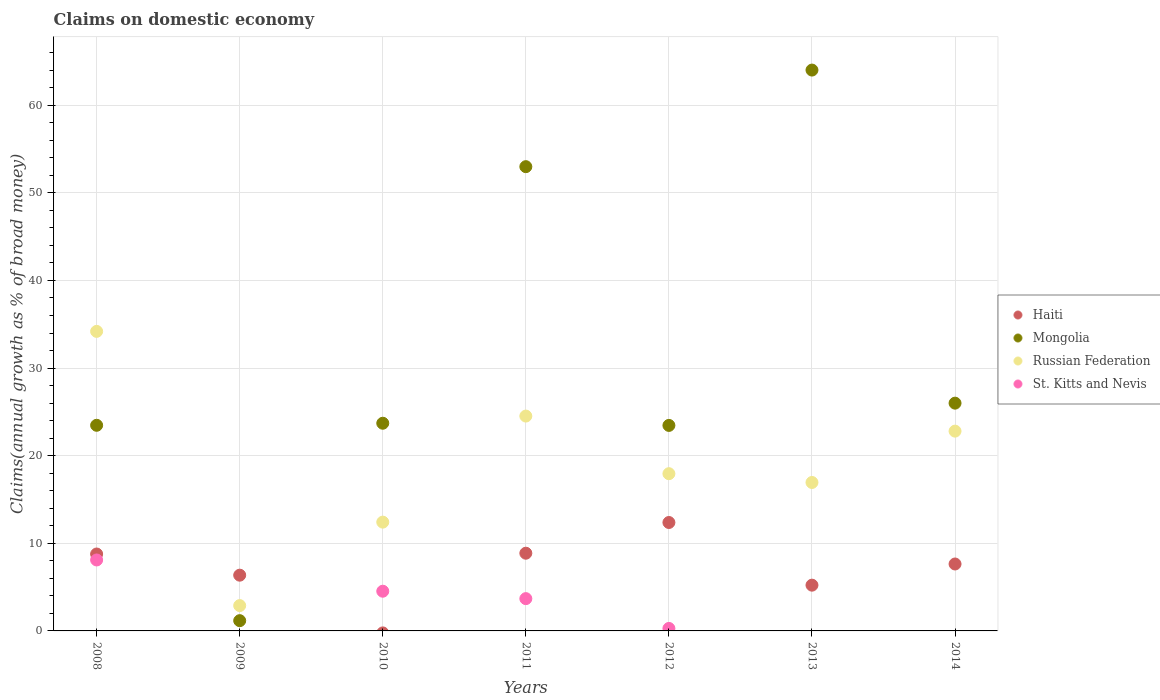Is the number of dotlines equal to the number of legend labels?
Keep it short and to the point. No. What is the percentage of broad money claimed on domestic economy in Russian Federation in 2010?
Offer a terse response. 12.42. Across all years, what is the maximum percentage of broad money claimed on domestic economy in Russian Federation?
Provide a succinct answer. 34.19. Across all years, what is the minimum percentage of broad money claimed on domestic economy in Mongolia?
Your response must be concise. 1.17. In which year was the percentage of broad money claimed on domestic economy in Mongolia maximum?
Your answer should be very brief. 2013. What is the total percentage of broad money claimed on domestic economy in St. Kitts and Nevis in the graph?
Your answer should be compact. 16.6. What is the difference between the percentage of broad money claimed on domestic economy in Mongolia in 2011 and that in 2014?
Your answer should be very brief. 26.99. What is the difference between the percentage of broad money claimed on domestic economy in St. Kitts and Nevis in 2014 and the percentage of broad money claimed on domestic economy in Mongolia in 2009?
Keep it short and to the point. -1.17. What is the average percentage of broad money claimed on domestic economy in Haiti per year?
Offer a terse response. 7.03. In the year 2009, what is the difference between the percentage of broad money claimed on domestic economy in Mongolia and percentage of broad money claimed on domestic economy in Russian Federation?
Your answer should be very brief. -1.72. What is the ratio of the percentage of broad money claimed on domestic economy in Haiti in 2008 to that in 2012?
Give a very brief answer. 0.71. Is the difference between the percentage of broad money claimed on domestic economy in Mongolia in 2009 and 2012 greater than the difference between the percentage of broad money claimed on domestic economy in Russian Federation in 2009 and 2012?
Ensure brevity in your answer.  No. What is the difference between the highest and the second highest percentage of broad money claimed on domestic economy in Mongolia?
Provide a short and direct response. 11.02. What is the difference between the highest and the lowest percentage of broad money claimed on domestic economy in Russian Federation?
Provide a short and direct response. 31.3. In how many years, is the percentage of broad money claimed on domestic economy in Mongolia greater than the average percentage of broad money claimed on domestic economy in Mongolia taken over all years?
Provide a succinct answer. 2. Is the sum of the percentage of broad money claimed on domestic economy in Haiti in 2008 and 2012 greater than the maximum percentage of broad money claimed on domestic economy in Mongolia across all years?
Offer a terse response. No. Is the percentage of broad money claimed on domestic economy in St. Kitts and Nevis strictly greater than the percentage of broad money claimed on domestic economy in Mongolia over the years?
Offer a very short reply. No. Does the graph contain any zero values?
Your answer should be very brief. Yes. How many legend labels are there?
Keep it short and to the point. 4. What is the title of the graph?
Provide a short and direct response. Claims on domestic economy. Does "Canada" appear as one of the legend labels in the graph?
Provide a succinct answer. No. What is the label or title of the X-axis?
Provide a short and direct response. Years. What is the label or title of the Y-axis?
Offer a terse response. Claims(annual growth as % of broad money). What is the Claims(annual growth as % of broad money) in Haiti in 2008?
Provide a short and direct response. 8.78. What is the Claims(annual growth as % of broad money) in Mongolia in 2008?
Provide a short and direct response. 23.47. What is the Claims(annual growth as % of broad money) of Russian Federation in 2008?
Provide a succinct answer. 34.19. What is the Claims(annual growth as % of broad money) of St. Kitts and Nevis in 2008?
Your response must be concise. 8.1. What is the Claims(annual growth as % of broad money) in Haiti in 2009?
Your answer should be compact. 6.36. What is the Claims(annual growth as % of broad money) of Mongolia in 2009?
Your answer should be compact. 1.17. What is the Claims(annual growth as % of broad money) in Russian Federation in 2009?
Ensure brevity in your answer.  2.89. What is the Claims(annual growth as % of broad money) of St. Kitts and Nevis in 2009?
Ensure brevity in your answer.  0. What is the Claims(annual growth as % of broad money) in Mongolia in 2010?
Keep it short and to the point. 23.7. What is the Claims(annual growth as % of broad money) of Russian Federation in 2010?
Make the answer very short. 12.42. What is the Claims(annual growth as % of broad money) of St. Kitts and Nevis in 2010?
Make the answer very short. 4.53. What is the Claims(annual growth as % of broad money) of Haiti in 2011?
Give a very brief answer. 8.87. What is the Claims(annual growth as % of broad money) of Mongolia in 2011?
Offer a very short reply. 52.99. What is the Claims(annual growth as % of broad money) in Russian Federation in 2011?
Give a very brief answer. 24.52. What is the Claims(annual growth as % of broad money) of St. Kitts and Nevis in 2011?
Your answer should be very brief. 3.68. What is the Claims(annual growth as % of broad money) of Haiti in 2012?
Offer a terse response. 12.37. What is the Claims(annual growth as % of broad money) in Mongolia in 2012?
Your answer should be very brief. 23.46. What is the Claims(annual growth as % of broad money) of Russian Federation in 2012?
Provide a succinct answer. 17.95. What is the Claims(annual growth as % of broad money) in St. Kitts and Nevis in 2012?
Provide a short and direct response. 0.28. What is the Claims(annual growth as % of broad money) in Haiti in 2013?
Offer a very short reply. 5.22. What is the Claims(annual growth as % of broad money) in Mongolia in 2013?
Offer a very short reply. 64.01. What is the Claims(annual growth as % of broad money) in Russian Federation in 2013?
Provide a succinct answer. 16.94. What is the Claims(annual growth as % of broad money) of St. Kitts and Nevis in 2013?
Your response must be concise. 0. What is the Claims(annual growth as % of broad money) of Haiti in 2014?
Provide a succinct answer. 7.64. What is the Claims(annual growth as % of broad money) of Mongolia in 2014?
Ensure brevity in your answer.  26. What is the Claims(annual growth as % of broad money) in Russian Federation in 2014?
Give a very brief answer. 22.8. Across all years, what is the maximum Claims(annual growth as % of broad money) in Haiti?
Provide a short and direct response. 12.37. Across all years, what is the maximum Claims(annual growth as % of broad money) in Mongolia?
Offer a very short reply. 64.01. Across all years, what is the maximum Claims(annual growth as % of broad money) of Russian Federation?
Offer a very short reply. 34.19. Across all years, what is the maximum Claims(annual growth as % of broad money) of St. Kitts and Nevis?
Your answer should be compact. 8.1. Across all years, what is the minimum Claims(annual growth as % of broad money) of Haiti?
Provide a succinct answer. 0. Across all years, what is the minimum Claims(annual growth as % of broad money) in Mongolia?
Your response must be concise. 1.17. Across all years, what is the minimum Claims(annual growth as % of broad money) of Russian Federation?
Offer a terse response. 2.89. What is the total Claims(annual growth as % of broad money) in Haiti in the graph?
Provide a succinct answer. 49.24. What is the total Claims(annual growth as % of broad money) of Mongolia in the graph?
Ensure brevity in your answer.  214.79. What is the total Claims(annual growth as % of broad money) of Russian Federation in the graph?
Keep it short and to the point. 131.71. What is the total Claims(annual growth as % of broad money) in St. Kitts and Nevis in the graph?
Make the answer very short. 16.6. What is the difference between the Claims(annual growth as % of broad money) of Haiti in 2008 and that in 2009?
Provide a succinct answer. 2.42. What is the difference between the Claims(annual growth as % of broad money) of Mongolia in 2008 and that in 2009?
Ensure brevity in your answer.  22.3. What is the difference between the Claims(annual growth as % of broad money) in Russian Federation in 2008 and that in 2009?
Give a very brief answer. 31.3. What is the difference between the Claims(annual growth as % of broad money) of Mongolia in 2008 and that in 2010?
Offer a terse response. -0.23. What is the difference between the Claims(annual growth as % of broad money) of Russian Federation in 2008 and that in 2010?
Offer a terse response. 21.77. What is the difference between the Claims(annual growth as % of broad money) of St. Kitts and Nevis in 2008 and that in 2010?
Your response must be concise. 3.57. What is the difference between the Claims(annual growth as % of broad money) in Haiti in 2008 and that in 2011?
Ensure brevity in your answer.  -0.09. What is the difference between the Claims(annual growth as % of broad money) of Mongolia in 2008 and that in 2011?
Provide a succinct answer. -29.52. What is the difference between the Claims(annual growth as % of broad money) in Russian Federation in 2008 and that in 2011?
Provide a succinct answer. 9.67. What is the difference between the Claims(annual growth as % of broad money) in St. Kitts and Nevis in 2008 and that in 2011?
Keep it short and to the point. 4.41. What is the difference between the Claims(annual growth as % of broad money) in Haiti in 2008 and that in 2012?
Offer a terse response. -3.6. What is the difference between the Claims(annual growth as % of broad money) in Mongolia in 2008 and that in 2012?
Your answer should be compact. 0.01. What is the difference between the Claims(annual growth as % of broad money) of Russian Federation in 2008 and that in 2012?
Offer a terse response. 16.24. What is the difference between the Claims(annual growth as % of broad money) in St. Kitts and Nevis in 2008 and that in 2012?
Ensure brevity in your answer.  7.82. What is the difference between the Claims(annual growth as % of broad money) of Haiti in 2008 and that in 2013?
Provide a succinct answer. 3.56. What is the difference between the Claims(annual growth as % of broad money) of Mongolia in 2008 and that in 2013?
Give a very brief answer. -40.54. What is the difference between the Claims(annual growth as % of broad money) of Russian Federation in 2008 and that in 2013?
Offer a terse response. 17.25. What is the difference between the Claims(annual growth as % of broad money) of Haiti in 2008 and that in 2014?
Give a very brief answer. 1.14. What is the difference between the Claims(annual growth as % of broad money) of Mongolia in 2008 and that in 2014?
Provide a succinct answer. -2.53. What is the difference between the Claims(annual growth as % of broad money) of Russian Federation in 2008 and that in 2014?
Provide a succinct answer. 11.39. What is the difference between the Claims(annual growth as % of broad money) in Mongolia in 2009 and that in 2010?
Provide a short and direct response. -22.53. What is the difference between the Claims(annual growth as % of broad money) in Russian Federation in 2009 and that in 2010?
Provide a short and direct response. -9.53. What is the difference between the Claims(annual growth as % of broad money) of Haiti in 2009 and that in 2011?
Offer a terse response. -2.51. What is the difference between the Claims(annual growth as % of broad money) of Mongolia in 2009 and that in 2011?
Offer a terse response. -51.82. What is the difference between the Claims(annual growth as % of broad money) of Russian Federation in 2009 and that in 2011?
Provide a short and direct response. -21.63. What is the difference between the Claims(annual growth as % of broad money) of Haiti in 2009 and that in 2012?
Make the answer very short. -6.01. What is the difference between the Claims(annual growth as % of broad money) in Mongolia in 2009 and that in 2012?
Offer a very short reply. -22.28. What is the difference between the Claims(annual growth as % of broad money) in Russian Federation in 2009 and that in 2012?
Ensure brevity in your answer.  -15.05. What is the difference between the Claims(annual growth as % of broad money) in Haiti in 2009 and that in 2013?
Offer a terse response. 1.14. What is the difference between the Claims(annual growth as % of broad money) of Mongolia in 2009 and that in 2013?
Make the answer very short. -62.84. What is the difference between the Claims(annual growth as % of broad money) of Russian Federation in 2009 and that in 2013?
Keep it short and to the point. -14.05. What is the difference between the Claims(annual growth as % of broad money) of Haiti in 2009 and that in 2014?
Offer a terse response. -1.28. What is the difference between the Claims(annual growth as % of broad money) of Mongolia in 2009 and that in 2014?
Provide a succinct answer. -24.83. What is the difference between the Claims(annual growth as % of broad money) in Russian Federation in 2009 and that in 2014?
Keep it short and to the point. -19.91. What is the difference between the Claims(annual growth as % of broad money) in Mongolia in 2010 and that in 2011?
Offer a terse response. -29.28. What is the difference between the Claims(annual growth as % of broad money) in Russian Federation in 2010 and that in 2011?
Your answer should be very brief. -12.1. What is the difference between the Claims(annual growth as % of broad money) of St. Kitts and Nevis in 2010 and that in 2011?
Offer a very short reply. 0.85. What is the difference between the Claims(annual growth as % of broad money) in Mongolia in 2010 and that in 2012?
Provide a succinct answer. 0.25. What is the difference between the Claims(annual growth as % of broad money) of Russian Federation in 2010 and that in 2012?
Keep it short and to the point. -5.53. What is the difference between the Claims(annual growth as % of broad money) in St. Kitts and Nevis in 2010 and that in 2012?
Offer a terse response. 4.25. What is the difference between the Claims(annual growth as % of broad money) of Mongolia in 2010 and that in 2013?
Ensure brevity in your answer.  -40.31. What is the difference between the Claims(annual growth as % of broad money) of Russian Federation in 2010 and that in 2013?
Provide a succinct answer. -4.53. What is the difference between the Claims(annual growth as % of broad money) of Mongolia in 2010 and that in 2014?
Make the answer very short. -2.29. What is the difference between the Claims(annual growth as % of broad money) of Russian Federation in 2010 and that in 2014?
Give a very brief answer. -10.39. What is the difference between the Claims(annual growth as % of broad money) in Haiti in 2011 and that in 2012?
Give a very brief answer. -3.51. What is the difference between the Claims(annual growth as % of broad money) of Mongolia in 2011 and that in 2012?
Provide a succinct answer. 29.53. What is the difference between the Claims(annual growth as % of broad money) in Russian Federation in 2011 and that in 2012?
Provide a short and direct response. 6.58. What is the difference between the Claims(annual growth as % of broad money) in St. Kitts and Nevis in 2011 and that in 2012?
Your answer should be compact. 3.4. What is the difference between the Claims(annual growth as % of broad money) of Haiti in 2011 and that in 2013?
Ensure brevity in your answer.  3.65. What is the difference between the Claims(annual growth as % of broad money) in Mongolia in 2011 and that in 2013?
Ensure brevity in your answer.  -11.02. What is the difference between the Claims(annual growth as % of broad money) of Russian Federation in 2011 and that in 2013?
Provide a succinct answer. 7.58. What is the difference between the Claims(annual growth as % of broad money) in Haiti in 2011 and that in 2014?
Ensure brevity in your answer.  1.23. What is the difference between the Claims(annual growth as % of broad money) in Mongolia in 2011 and that in 2014?
Give a very brief answer. 26.99. What is the difference between the Claims(annual growth as % of broad money) of Russian Federation in 2011 and that in 2014?
Your answer should be very brief. 1.72. What is the difference between the Claims(annual growth as % of broad money) in Haiti in 2012 and that in 2013?
Ensure brevity in your answer.  7.15. What is the difference between the Claims(annual growth as % of broad money) in Mongolia in 2012 and that in 2013?
Offer a terse response. -40.55. What is the difference between the Claims(annual growth as % of broad money) in Haiti in 2012 and that in 2014?
Provide a succinct answer. 4.74. What is the difference between the Claims(annual growth as % of broad money) in Mongolia in 2012 and that in 2014?
Offer a very short reply. -2.54. What is the difference between the Claims(annual growth as % of broad money) in Russian Federation in 2012 and that in 2014?
Give a very brief answer. -4.86. What is the difference between the Claims(annual growth as % of broad money) of Haiti in 2013 and that in 2014?
Your answer should be very brief. -2.42. What is the difference between the Claims(annual growth as % of broad money) of Mongolia in 2013 and that in 2014?
Keep it short and to the point. 38.01. What is the difference between the Claims(annual growth as % of broad money) in Russian Federation in 2013 and that in 2014?
Ensure brevity in your answer.  -5.86. What is the difference between the Claims(annual growth as % of broad money) in Haiti in 2008 and the Claims(annual growth as % of broad money) in Mongolia in 2009?
Keep it short and to the point. 7.61. What is the difference between the Claims(annual growth as % of broad money) of Haiti in 2008 and the Claims(annual growth as % of broad money) of Russian Federation in 2009?
Ensure brevity in your answer.  5.89. What is the difference between the Claims(annual growth as % of broad money) of Mongolia in 2008 and the Claims(annual growth as % of broad money) of Russian Federation in 2009?
Provide a short and direct response. 20.58. What is the difference between the Claims(annual growth as % of broad money) in Haiti in 2008 and the Claims(annual growth as % of broad money) in Mongolia in 2010?
Offer a very short reply. -14.93. What is the difference between the Claims(annual growth as % of broad money) in Haiti in 2008 and the Claims(annual growth as % of broad money) in Russian Federation in 2010?
Offer a terse response. -3.64. What is the difference between the Claims(annual growth as % of broad money) of Haiti in 2008 and the Claims(annual growth as % of broad money) of St. Kitts and Nevis in 2010?
Keep it short and to the point. 4.25. What is the difference between the Claims(annual growth as % of broad money) of Mongolia in 2008 and the Claims(annual growth as % of broad money) of Russian Federation in 2010?
Offer a terse response. 11.05. What is the difference between the Claims(annual growth as % of broad money) of Mongolia in 2008 and the Claims(annual growth as % of broad money) of St. Kitts and Nevis in 2010?
Offer a very short reply. 18.94. What is the difference between the Claims(annual growth as % of broad money) in Russian Federation in 2008 and the Claims(annual growth as % of broad money) in St. Kitts and Nevis in 2010?
Make the answer very short. 29.66. What is the difference between the Claims(annual growth as % of broad money) of Haiti in 2008 and the Claims(annual growth as % of broad money) of Mongolia in 2011?
Provide a succinct answer. -44.21. What is the difference between the Claims(annual growth as % of broad money) in Haiti in 2008 and the Claims(annual growth as % of broad money) in Russian Federation in 2011?
Ensure brevity in your answer.  -15.74. What is the difference between the Claims(annual growth as % of broad money) in Haiti in 2008 and the Claims(annual growth as % of broad money) in St. Kitts and Nevis in 2011?
Provide a short and direct response. 5.09. What is the difference between the Claims(annual growth as % of broad money) of Mongolia in 2008 and the Claims(annual growth as % of broad money) of Russian Federation in 2011?
Provide a short and direct response. -1.05. What is the difference between the Claims(annual growth as % of broad money) in Mongolia in 2008 and the Claims(annual growth as % of broad money) in St. Kitts and Nevis in 2011?
Provide a succinct answer. 19.78. What is the difference between the Claims(annual growth as % of broad money) in Russian Federation in 2008 and the Claims(annual growth as % of broad money) in St. Kitts and Nevis in 2011?
Ensure brevity in your answer.  30.5. What is the difference between the Claims(annual growth as % of broad money) in Haiti in 2008 and the Claims(annual growth as % of broad money) in Mongolia in 2012?
Give a very brief answer. -14.68. What is the difference between the Claims(annual growth as % of broad money) of Haiti in 2008 and the Claims(annual growth as % of broad money) of Russian Federation in 2012?
Provide a succinct answer. -9.17. What is the difference between the Claims(annual growth as % of broad money) of Haiti in 2008 and the Claims(annual growth as % of broad money) of St. Kitts and Nevis in 2012?
Your answer should be very brief. 8.5. What is the difference between the Claims(annual growth as % of broad money) of Mongolia in 2008 and the Claims(annual growth as % of broad money) of Russian Federation in 2012?
Offer a terse response. 5.52. What is the difference between the Claims(annual growth as % of broad money) of Mongolia in 2008 and the Claims(annual growth as % of broad money) of St. Kitts and Nevis in 2012?
Make the answer very short. 23.19. What is the difference between the Claims(annual growth as % of broad money) of Russian Federation in 2008 and the Claims(annual growth as % of broad money) of St. Kitts and Nevis in 2012?
Offer a terse response. 33.9. What is the difference between the Claims(annual growth as % of broad money) of Haiti in 2008 and the Claims(annual growth as % of broad money) of Mongolia in 2013?
Your response must be concise. -55.23. What is the difference between the Claims(annual growth as % of broad money) of Haiti in 2008 and the Claims(annual growth as % of broad money) of Russian Federation in 2013?
Your answer should be very brief. -8.16. What is the difference between the Claims(annual growth as % of broad money) of Mongolia in 2008 and the Claims(annual growth as % of broad money) of Russian Federation in 2013?
Your answer should be very brief. 6.53. What is the difference between the Claims(annual growth as % of broad money) of Haiti in 2008 and the Claims(annual growth as % of broad money) of Mongolia in 2014?
Your answer should be very brief. -17.22. What is the difference between the Claims(annual growth as % of broad money) of Haiti in 2008 and the Claims(annual growth as % of broad money) of Russian Federation in 2014?
Offer a terse response. -14.02. What is the difference between the Claims(annual growth as % of broad money) of Mongolia in 2008 and the Claims(annual growth as % of broad money) of Russian Federation in 2014?
Your response must be concise. 0.67. What is the difference between the Claims(annual growth as % of broad money) in Haiti in 2009 and the Claims(annual growth as % of broad money) in Mongolia in 2010?
Your response must be concise. -17.34. What is the difference between the Claims(annual growth as % of broad money) of Haiti in 2009 and the Claims(annual growth as % of broad money) of Russian Federation in 2010?
Offer a very short reply. -6.05. What is the difference between the Claims(annual growth as % of broad money) of Haiti in 2009 and the Claims(annual growth as % of broad money) of St. Kitts and Nevis in 2010?
Your answer should be very brief. 1.83. What is the difference between the Claims(annual growth as % of broad money) in Mongolia in 2009 and the Claims(annual growth as % of broad money) in Russian Federation in 2010?
Keep it short and to the point. -11.25. What is the difference between the Claims(annual growth as % of broad money) of Mongolia in 2009 and the Claims(annual growth as % of broad money) of St. Kitts and Nevis in 2010?
Ensure brevity in your answer.  -3.36. What is the difference between the Claims(annual growth as % of broad money) in Russian Federation in 2009 and the Claims(annual growth as % of broad money) in St. Kitts and Nevis in 2010?
Give a very brief answer. -1.64. What is the difference between the Claims(annual growth as % of broad money) in Haiti in 2009 and the Claims(annual growth as % of broad money) in Mongolia in 2011?
Provide a short and direct response. -46.62. What is the difference between the Claims(annual growth as % of broad money) of Haiti in 2009 and the Claims(annual growth as % of broad money) of Russian Federation in 2011?
Provide a short and direct response. -18.16. What is the difference between the Claims(annual growth as % of broad money) of Haiti in 2009 and the Claims(annual growth as % of broad money) of St. Kitts and Nevis in 2011?
Provide a succinct answer. 2.68. What is the difference between the Claims(annual growth as % of broad money) in Mongolia in 2009 and the Claims(annual growth as % of broad money) in Russian Federation in 2011?
Offer a terse response. -23.35. What is the difference between the Claims(annual growth as % of broad money) in Mongolia in 2009 and the Claims(annual growth as % of broad money) in St. Kitts and Nevis in 2011?
Offer a terse response. -2.51. What is the difference between the Claims(annual growth as % of broad money) of Russian Federation in 2009 and the Claims(annual growth as % of broad money) of St. Kitts and Nevis in 2011?
Make the answer very short. -0.79. What is the difference between the Claims(annual growth as % of broad money) of Haiti in 2009 and the Claims(annual growth as % of broad money) of Mongolia in 2012?
Your response must be concise. -17.09. What is the difference between the Claims(annual growth as % of broad money) of Haiti in 2009 and the Claims(annual growth as % of broad money) of Russian Federation in 2012?
Give a very brief answer. -11.58. What is the difference between the Claims(annual growth as % of broad money) of Haiti in 2009 and the Claims(annual growth as % of broad money) of St. Kitts and Nevis in 2012?
Ensure brevity in your answer.  6.08. What is the difference between the Claims(annual growth as % of broad money) in Mongolia in 2009 and the Claims(annual growth as % of broad money) in Russian Federation in 2012?
Offer a very short reply. -16.78. What is the difference between the Claims(annual growth as % of broad money) of Mongolia in 2009 and the Claims(annual growth as % of broad money) of St. Kitts and Nevis in 2012?
Your answer should be very brief. 0.89. What is the difference between the Claims(annual growth as % of broad money) in Russian Federation in 2009 and the Claims(annual growth as % of broad money) in St. Kitts and Nevis in 2012?
Give a very brief answer. 2.61. What is the difference between the Claims(annual growth as % of broad money) in Haiti in 2009 and the Claims(annual growth as % of broad money) in Mongolia in 2013?
Give a very brief answer. -57.65. What is the difference between the Claims(annual growth as % of broad money) of Haiti in 2009 and the Claims(annual growth as % of broad money) of Russian Federation in 2013?
Give a very brief answer. -10.58. What is the difference between the Claims(annual growth as % of broad money) in Mongolia in 2009 and the Claims(annual growth as % of broad money) in Russian Federation in 2013?
Keep it short and to the point. -15.77. What is the difference between the Claims(annual growth as % of broad money) of Haiti in 2009 and the Claims(annual growth as % of broad money) of Mongolia in 2014?
Keep it short and to the point. -19.63. What is the difference between the Claims(annual growth as % of broad money) of Haiti in 2009 and the Claims(annual growth as % of broad money) of Russian Federation in 2014?
Offer a very short reply. -16.44. What is the difference between the Claims(annual growth as % of broad money) in Mongolia in 2009 and the Claims(annual growth as % of broad money) in Russian Federation in 2014?
Provide a succinct answer. -21.63. What is the difference between the Claims(annual growth as % of broad money) in Mongolia in 2010 and the Claims(annual growth as % of broad money) in Russian Federation in 2011?
Make the answer very short. -0.82. What is the difference between the Claims(annual growth as % of broad money) in Mongolia in 2010 and the Claims(annual growth as % of broad money) in St. Kitts and Nevis in 2011?
Your answer should be compact. 20.02. What is the difference between the Claims(annual growth as % of broad money) of Russian Federation in 2010 and the Claims(annual growth as % of broad money) of St. Kitts and Nevis in 2011?
Your answer should be compact. 8.73. What is the difference between the Claims(annual growth as % of broad money) in Mongolia in 2010 and the Claims(annual growth as % of broad money) in Russian Federation in 2012?
Your answer should be very brief. 5.76. What is the difference between the Claims(annual growth as % of broad money) of Mongolia in 2010 and the Claims(annual growth as % of broad money) of St. Kitts and Nevis in 2012?
Your answer should be compact. 23.42. What is the difference between the Claims(annual growth as % of broad money) of Russian Federation in 2010 and the Claims(annual growth as % of broad money) of St. Kitts and Nevis in 2012?
Your response must be concise. 12.13. What is the difference between the Claims(annual growth as % of broad money) of Mongolia in 2010 and the Claims(annual growth as % of broad money) of Russian Federation in 2013?
Keep it short and to the point. 6.76. What is the difference between the Claims(annual growth as % of broad money) in Mongolia in 2010 and the Claims(annual growth as % of broad money) in Russian Federation in 2014?
Your response must be concise. 0.9. What is the difference between the Claims(annual growth as % of broad money) of Haiti in 2011 and the Claims(annual growth as % of broad money) of Mongolia in 2012?
Provide a short and direct response. -14.59. What is the difference between the Claims(annual growth as % of broad money) in Haiti in 2011 and the Claims(annual growth as % of broad money) in Russian Federation in 2012?
Make the answer very short. -9.08. What is the difference between the Claims(annual growth as % of broad money) of Haiti in 2011 and the Claims(annual growth as % of broad money) of St. Kitts and Nevis in 2012?
Your answer should be compact. 8.59. What is the difference between the Claims(annual growth as % of broad money) in Mongolia in 2011 and the Claims(annual growth as % of broad money) in Russian Federation in 2012?
Ensure brevity in your answer.  35.04. What is the difference between the Claims(annual growth as % of broad money) in Mongolia in 2011 and the Claims(annual growth as % of broad money) in St. Kitts and Nevis in 2012?
Your response must be concise. 52.7. What is the difference between the Claims(annual growth as % of broad money) of Russian Federation in 2011 and the Claims(annual growth as % of broad money) of St. Kitts and Nevis in 2012?
Provide a succinct answer. 24.24. What is the difference between the Claims(annual growth as % of broad money) in Haiti in 2011 and the Claims(annual growth as % of broad money) in Mongolia in 2013?
Your answer should be very brief. -55.14. What is the difference between the Claims(annual growth as % of broad money) in Haiti in 2011 and the Claims(annual growth as % of broad money) in Russian Federation in 2013?
Your answer should be compact. -8.07. What is the difference between the Claims(annual growth as % of broad money) of Mongolia in 2011 and the Claims(annual growth as % of broad money) of Russian Federation in 2013?
Make the answer very short. 36.04. What is the difference between the Claims(annual growth as % of broad money) of Haiti in 2011 and the Claims(annual growth as % of broad money) of Mongolia in 2014?
Provide a short and direct response. -17.13. What is the difference between the Claims(annual growth as % of broad money) in Haiti in 2011 and the Claims(annual growth as % of broad money) in Russian Federation in 2014?
Offer a very short reply. -13.93. What is the difference between the Claims(annual growth as % of broad money) of Mongolia in 2011 and the Claims(annual growth as % of broad money) of Russian Federation in 2014?
Keep it short and to the point. 30.18. What is the difference between the Claims(annual growth as % of broad money) in Haiti in 2012 and the Claims(annual growth as % of broad money) in Mongolia in 2013?
Provide a short and direct response. -51.64. What is the difference between the Claims(annual growth as % of broad money) in Haiti in 2012 and the Claims(annual growth as % of broad money) in Russian Federation in 2013?
Give a very brief answer. -4.57. What is the difference between the Claims(annual growth as % of broad money) in Mongolia in 2012 and the Claims(annual growth as % of broad money) in Russian Federation in 2013?
Your response must be concise. 6.51. What is the difference between the Claims(annual growth as % of broad money) in Haiti in 2012 and the Claims(annual growth as % of broad money) in Mongolia in 2014?
Ensure brevity in your answer.  -13.62. What is the difference between the Claims(annual growth as % of broad money) of Haiti in 2012 and the Claims(annual growth as % of broad money) of Russian Federation in 2014?
Ensure brevity in your answer.  -10.43. What is the difference between the Claims(annual growth as % of broad money) of Mongolia in 2012 and the Claims(annual growth as % of broad money) of Russian Federation in 2014?
Your response must be concise. 0.65. What is the difference between the Claims(annual growth as % of broad money) in Haiti in 2013 and the Claims(annual growth as % of broad money) in Mongolia in 2014?
Ensure brevity in your answer.  -20.77. What is the difference between the Claims(annual growth as % of broad money) in Haiti in 2013 and the Claims(annual growth as % of broad money) in Russian Federation in 2014?
Ensure brevity in your answer.  -17.58. What is the difference between the Claims(annual growth as % of broad money) of Mongolia in 2013 and the Claims(annual growth as % of broad money) of Russian Federation in 2014?
Your answer should be compact. 41.21. What is the average Claims(annual growth as % of broad money) in Haiti per year?
Your answer should be very brief. 7.03. What is the average Claims(annual growth as % of broad money) of Mongolia per year?
Your response must be concise. 30.68. What is the average Claims(annual growth as % of broad money) in Russian Federation per year?
Ensure brevity in your answer.  18.82. What is the average Claims(annual growth as % of broad money) of St. Kitts and Nevis per year?
Give a very brief answer. 2.37. In the year 2008, what is the difference between the Claims(annual growth as % of broad money) in Haiti and Claims(annual growth as % of broad money) in Mongolia?
Provide a short and direct response. -14.69. In the year 2008, what is the difference between the Claims(annual growth as % of broad money) in Haiti and Claims(annual growth as % of broad money) in Russian Federation?
Your answer should be compact. -25.41. In the year 2008, what is the difference between the Claims(annual growth as % of broad money) of Haiti and Claims(annual growth as % of broad money) of St. Kitts and Nevis?
Your answer should be compact. 0.68. In the year 2008, what is the difference between the Claims(annual growth as % of broad money) of Mongolia and Claims(annual growth as % of broad money) of Russian Federation?
Ensure brevity in your answer.  -10.72. In the year 2008, what is the difference between the Claims(annual growth as % of broad money) in Mongolia and Claims(annual growth as % of broad money) in St. Kitts and Nevis?
Your answer should be very brief. 15.37. In the year 2008, what is the difference between the Claims(annual growth as % of broad money) of Russian Federation and Claims(annual growth as % of broad money) of St. Kitts and Nevis?
Offer a very short reply. 26.09. In the year 2009, what is the difference between the Claims(annual growth as % of broad money) of Haiti and Claims(annual growth as % of broad money) of Mongolia?
Provide a succinct answer. 5.19. In the year 2009, what is the difference between the Claims(annual growth as % of broad money) of Haiti and Claims(annual growth as % of broad money) of Russian Federation?
Ensure brevity in your answer.  3.47. In the year 2009, what is the difference between the Claims(annual growth as % of broad money) of Mongolia and Claims(annual growth as % of broad money) of Russian Federation?
Keep it short and to the point. -1.72. In the year 2010, what is the difference between the Claims(annual growth as % of broad money) in Mongolia and Claims(annual growth as % of broad money) in Russian Federation?
Ensure brevity in your answer.  11.29. In the year 2010, what is the difference between the Claims(annual growth as % of broad money) of Mongolia and Claims(annual growth as % of broad money) of St. Kitts and Nevis?
Ensure brevity in your answer.  19.17. In the year 2010, what is the difference between the Claims(annual growth as % of broad money) of Russian Federation and Claims(annual growth as % of broad money) of St. Kitts and Nevis?
Keep it short and to the point. 7.88. In the year 2011, what is the difference between the Claims(annual growth as % of broad money) of Haiti and Claims(annual growth as % of broad money) of Mongolia?
Provide a succinct answer. -44.12. In the year 2011, what is the difference between the Claims(annual growth as % of broad money) of Haiti and Claims(annual growth as % of broad money) of Russian Federation?
Give a very brief answer. -15.65. In the year 2011, what is the difference between the Claims(annual growth as % of broad money) in Haiti and Claims(annual growth as % of broad money) in St. Kitts and Nevis?
Provide a succinct answer. 5.18. In the year 2011, what is the difference between the Claims(annual growth as % of broad money) in Mongolia and Claims(annual growth as % of broad money) in Russian Federation?
Your answer should be compact. 28.46. In the year 2011, what is the difference between the Claims(annual growth as % of broad money) of Mongolia and Claims(annual growth as % of broad money) of St. Kitts and Nevis?
Provide a succinct answer. 49.3. In the year 2011, what is the difference between the Claims(annual growth as % of broad money) of Russian Federation and Claims(annual growth as % of broad money) of St. Kitts and Nevis?
Give a very brief answer. 20.84. In the year 2012, what is the difference between the Claims(annual growth as % of broad money) in Haiti and Claims(annual growth as % of broad money) in Mongolia?
Make the answer very short. -11.08. In the year 2012, what is the difference between the Claims(annual growth as % of broad money) of Haiti and Claims(annual growth as % of broad money) of Russian Federation?
Your response must be concise. -5.57. In the year 2012, what is the difference between the Claims(annual growth as % of broad money) in Haiti and Claims(annual growth as % of broad money) in St. Kitts and Nevis?
Give a very brief answer. 12.09. In the year 2012, what is the difference between the Claims(annual growth as % of broad money) in Mongolia and Claims(annual growth as % of broad money) in Russian Federation?
Give a very brief answer. 5.51. In the year 2012, what is the difference between the Claims(annual growth as % of broad money) of Mongolia and Claims(annual growth as % of broad money) of St. Kitts and Nevis?
Make the answer very short. 23.17. In the year 2012, what is the difference between the Claims(annual growth as % of broad money) in Russian Federation and Claims(annual growth as % of broad money) in St. Kitts and Nevis?
Keep it short and to the point. 17.66. In the year 2013, what is the difference between the Claims(annual growth as % of broad money) of Haiti and Claims(annual growth as % of broad money) of Mongolia?
Give a very brief answer. -58.79. In the year 2013, what is the difference between the Claims(annual growth as % of broad money) of Haiti and Claims(annual growth as % of broad money) of Russian Federation?
Ensure brevity in your answer.  -11.72. In the year 2013, what is the difference between the Claims(annual growth as % of broad money) of Mongolia and Claims(annual growth as % of broad money) of Russian Federation?
Your answer should be compact. 47.07. In the year 2014, what is the difference between the Claims(annual growth as % of broad money) of Haiti and Claims(annual growth as % of broad money) of Mongolia?
Give a very brief answer. -18.36. In the year 2014, what is the difference between the Claims(annual growth as % of broad money) in Haiti and Claims(annual growth as % of broad money) in Russian Federation?
Make the answer very short. -15.16. In the year 2014, what is the difference between the Claims(annual growth as % of broad money) in Mongolia and Claims(annual growth as % of broad money) in Russian Federation?
Offer a terse response. 3.19. What is the ratio of the Claims(annual growth as % of broad money) of Haiti in 2008 to that in 2009?
Provide a short and direct response. 1.38. What is the ratio of the Claims(annual growth as % of broad money) in Mongolia in 2008 to that in 2009?
Provide a succinct answer. 20.05. What is the ratio of the Claims(annual growth as % of broad money) in Russian Federation in 2008 to that in 2009?
Your answer should be very brief. 11.83. What is the ratio of the Claims(annual growth as % of broad money) of Mongolia in 2008 to that in 2010?
Your answer should be compact. 0.99. What is the ratio of the Claims(annual growth as % of broad money) of Russian Federation in 2008 to that in 2010?
Your answer should be very brief. 2.75. What is the ratio of the Claims(annual growth as % of broad money) of St. Kitts and Nevis in 2008 to that in 2010?
Make the answer very short. 1.79. What is the ratio of the Claims(annual growth as % of broad money) in Haiti in 2008 to that in 2011?
Your response must be concise. 0.99. What is the ratio of the Claims(annual growth as % of broad money) of Mongolia in 2008 to that in 2011?
Offer a terse response. 0.44. What is the ratio of the Claims(annual growth as % of broad money) in Russian Federation in 2008 to that in 2011?
Keep it short and to the point. 1.39. What is the ratio of the Claims(annual growth as % of broad money) of St. Kitts and Nevis in 2008 to that in 2011?
Provide a succinct answer. 2.2. What is the ratio of the Claims(annual growth as % of broad money) of Haiti in 2008 to that in 2012?
Ensure brevity in your answer.  0.71. What is the ratio of the Claims(annual growth as % of broad money) of Russian Federation in 2008 to that in 2012?
Make the answer very short. 1.91. What is the ratio of the Claims(annual growth as % of broad money) in St. Kitts and Nevis in 2008 to that in 2012?
Your answer should be very brief. 28.64. What is the ratio of the Claims(annual growth as % of broad money) of Haiti in 2008 to that in 2013?
Your answer should be compact. 1.68. What is the ratio of the Claims(annual growth as % of broad money) in Mongolia in 2008 to that in 2013?
Offer a terse response. 0.37. What is the ratio of the Claims(annual growth as % of broad money) in Russian Federation in 2008 to that in 2013?
Your answer should be very brief. 2.02. What is the ratio of the Claims(annual growth as % of broad money) of Haiti in 2008 to that in 2014?
Keep it short and to the point. 1.15. What is the ratio of the Claims(annual growth as % of broad money) of Mongolia in 2008 to that in 2014?
Your response must be concise. 0.9. What is the ratio of the Claims(annual growth as % of broad money) of Russian Federation in 2008 to that in 2014?
Provide a succinct answer. 1.5. What is the ratio of the Claims(annual growth as % of broad money) in Mongolia in 2009 to that in 2010?
Your response must be concise. 0.05. What is the ratio of the Claims(annual growth as % of broad money) in Russian Federation in 2009 to that in 2010?
Provide a short and direct response. 0.23. What is the ratio of the Claims(annual growth as % of broad money) of Haiti in 2009 to that in 2011?
Make the answer very short. 0.72. What is the ratio of the Claims(annual growth as % of broad money) of Mongolia in 2009 to that in 2011?
Your answer should be very brief. 0.02. What is the ratio of the Claims(annual growth as % of broad money) of Russian Federation in 2009 to that in 2011?
Your answer should be very brief. 0.12. What is the ratio of the Claims(annual growth as % of broad money) of Haiti in 2009 to that in 2012?
Provide a short and direct response. 0.51. What is the ratio of the Claims(annual growth as % of broad money) in Mongolia in 2009 to that in 2012?
Make the answer very short. 0.05. What is the ratio of the Claims(annual growth as % of broad money) of Russian Federation in 2009 to that in 2012?
Ensure brevity in your answer.  0.16. What is the ratio of the Claims(annual growth as % of broad money) of Haiti in 2009 to that in 2013?
Give a very brief answer. 1.22. What is the ratio of the Claims(annual growth as % of broad money) in Mongolia in 2009 to that in 2013?
Make the answer very short. 0.02. What is the ratio of the Claims(annual growth as % of broad money) in Russian Federation in 2009 to that in 2013?
Keep it short and to the point. 0.17. What is the ratio of the Claims(annual growth as % of broad money) in Haiti in 2009 to that in 2014?
Provide a short and direct response. 0.83. What is the ratio of the Claims(annual growth as % of broad money) of Mongolia in 2009 to that in 2014?
Give a very brief answer. 0.04. What is the ratio of the Claims(annual growth as % of broad money) of Russian Federation in 2009 to that in 2014?
Ensure brevity in your answer.  0.13. What is the ratio of the Claims(annual growth as % of broad money) in Mongolia in 2010 to that in 2011?
Ensure brevity in your answer.  0.45. What is the ratio of the Claims(annual growth as % of broad money) of Russian Federation in 2010 to that in 2011?
Offer a terse response. 0.51. What is the ratio of the Claims(annual growth as % of broad money) in St. Kitts and Nevis in 2010 to that in 2011?
Your response must be concise. 1.23. What is the ratio of the Claims(annual growth as % of broad money) of Mongolia in 2010 to that in 2012?
Offer a terse response. 1.01. What is the ratio of the Claims(annual growth as % of broad money) of Russian Federation in 2010 to that in 2012?
Offer a very short reply. 0.69. What is the ratio of the Claims(annual growth as % of broad money) of St. Kitts and Nevis in 2010 to that in 2012?
Provide a succinct answer. 16.02. What is the ratio of the Claims(annual growth as % of broad money) of Mongolia in 2010 to that in 2013?
Your answer should be compact. 0.37. What is the ratio of the Claims(annual growth as % of broad money) in Russian Federation in 2010 to that in 2013?
Make the answer very short. 0.73. What is the ratio of the Claims(annual growth as % of broad money) of Mongolia in 2010 to that in 2014?
Offer a very short reply. 0.91. What is the ratio of the Claims(annual growth as % of broad money) in Russian Federation in 2010 to that in 2014?
Keep it short and to the point. 0.54. What is the ratio of the Claims(annual growth as % of broad money) of Haiti in 2011 to that in 2012?
Provide a succinct answer. 0.72. What is the ratio of the Claims(annual growth as % of broad money) in Mongolia in 2011 to that in 2012?
Your answer should be very brief. 2.26. What is the ratio of the Claims(annual growth as % of broad money) of Russian Federation in 2011 to that in 2012?
Your response must be concise. 1.37. What is the ratio of the Claims(annual growth as % of broad money) of St. Kitts and Nevis in 2011 to that in 2012?
Provide a short and direct response. 13.03. What is the ratio of the Claims(annual growth as % of broad money) of Haiti in 2011 to that in 2013?
Make the answer very short. 1.7. What is the ratio of the Claims(annual growth as % of broad money) in Mongolia in 2011 to that in 2013?
Offer a terse response. 0.83. What is the ratio of the Claims(annual growth as % of broad money) of Russian Federation in 2011 to that in 2013?
Offer a very short reply. 1.45. What is the ratio of the Claims(annual growth as % of broad money) in Haiti in 2011 to that in 2014?
Your answer should be very brief. 1.16. What is the ratio of the Claims(annual growth as % of broad money) of Mongolia in 2011 to that in 2014?
Your answer should be very brief. 2.04. What is the ratio of the Claims(annual growth as % of broad money) of Russian Federation in 2011 to that in 2014?
Offer a very short reply. 1.08. What is the ratio of the Claims(annual growth as % of broad money) of Haiti in 2012 to that in 2013?
Keep it short and to the point. 2.37. What is the ratio of the Claims(annual growth as % of broad money) in Mongolia in 2012 to that in 2013?
Your response must be concise. 0.37. What is the ratio of the Claims(annual growth as % of broad money) in Russian Federation in 2012 to that in 2013?
Your answer should be very brief. 1.06. What is the ratio of the Claims(annual growth as % of broad money) of Haiti in 2012 to that in 2014?
Provide a succinct answer. 1.62. What is the ratio of the Claims(annual growth as % of broad money) of Mongolia in 2012 to that in 2014?
Give a very brief answer. 0.9. What is the ratio of the Claims(annual growth as % of broad money) in Russian Federation in 2012 to that in 2014?
Provide a succinct answer. 0.79. What is the ratio of the Claims(annual growth as % of broad money) of Haiti in 2013 to that in 2014?
Keep it short and to the point. 0.68. What is the ratio of the Claims(annual growth as % of broad money) in Mongolia in 2013 to that in 2014?
Keep it short and to the point. 2.46. What is the ratio of the Claims(annual growth as % of broad money) of Russian Federation in 2013 to that in 2014?
Keep it short and to the point. 0.74. What is the difference between the highest and the second highest Claims(annual growth as % of broad money) in Haiti?
Your answer should be compact. 3.51. What is the difference between the highest and the second highest Claims(annual growth as % of broad money) of Mongolia?
Ensure brevity in your answer.  11.02. What is the difference between the highest and the second highest Claims(annual growth as % of broad money) of Russian Federation?
Keep it short and to the point. 9.67. What is the difference between the highest and the second highest Claims(annual growth as % of broad money) of St. Kitts and Nevis?
Provide a succinct answer. 3.57. What is the difference between the highest and the lowest Claims(annual growth as % of broad money) of Haiti?
Offer a terse response. 12.37. What is the difference between the highest and the lowest Claims(annual growth as % of broad money) of Mongolia?
Offer a terse response. 62.84. What is the difference between the highest and the lowest Claims(annual growth as % of broad money) in Russian Federation?
Your answer should be very brief. 31.3. What is the difference between the highest and the lowest Claims(annual growth as % of broad money) in St. Kitts and Nevis?
Provide a succinct answer. 8.1. 